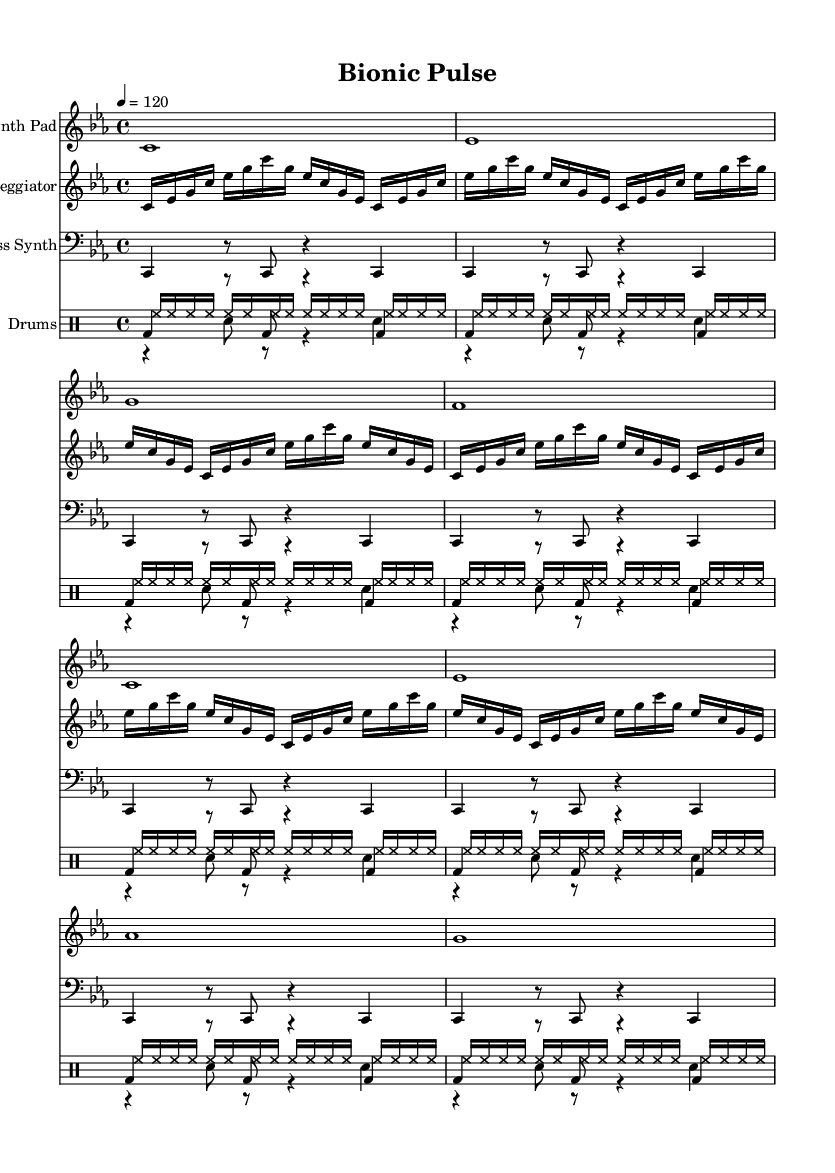What is the key signature of this music? The key signature is C minor, which is indicated by three flats in the staff at the beginning of the piece.
Answer: C minor What is the time signature of this music? The time signature shown is 4/4, which is indicated at the beginning of the score and tells us there are four beats in each measure.
Answer: 4/4 What is the tempo marking for this piece? The tempo is set at 120 beats per minute, as indicated by the tempo marking above the staff at the beginning of the score.
Answer: 120 How many measures does the arpeggiator part repeat? The arpeggiator part has a "repeat unfold" marking of 8, meaning it repeats the sequence 8 times within that section.
Answer: 8 Which instruments are used in this composition? The composition features a Synth Pad, Arpeggiator, Bass Synth, and a Drum set with kick drum, snare drum, and hi-hat, as indicated at the start of each staff.
Answer: Synth Pad, Arpeggiator, Bass Synth, Drums What type of rhythm is created by the hi-hat in this piece? The hi-hat pattern consists of sixteenth notes played continuously, which creates a driving rhythmic feel typical in dance music.
Answer: Sixteenth notes What kind of electronic elements are present in this piece? The presence of synthesized sounds like Synth Pad and Bass Synth, along with digital percussion, showcases the bionic and cyborg-inspired elements typical in ambient electronica.
Answer: Synthesized sounds 